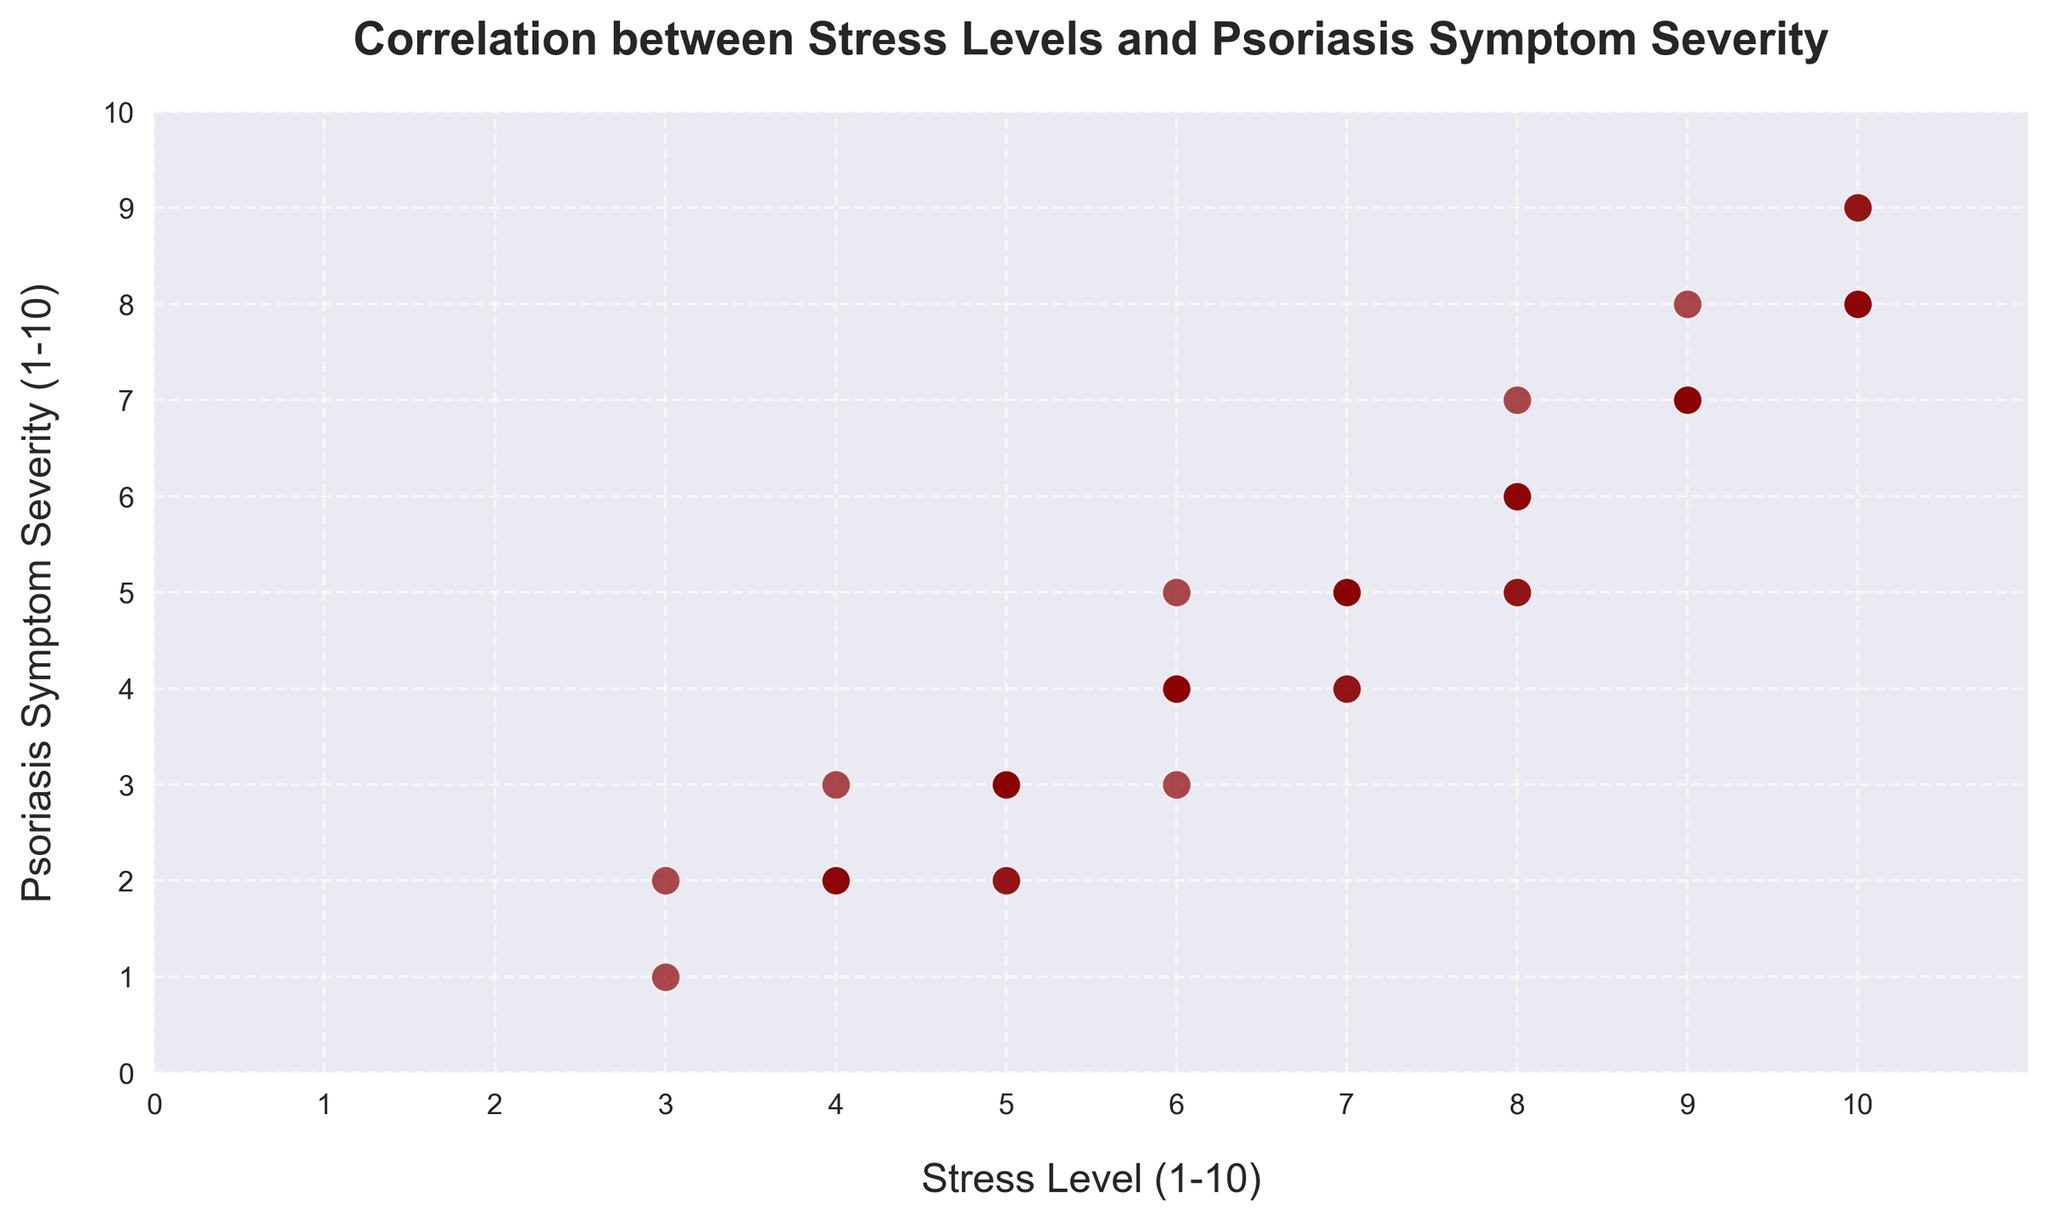What is the range of the stress levels shown in the plot? The stress levels range from the lowest point to the highest point plotted on the x-axis. From the plot, stress levels range from 3 to 10.
Answer: 3 to 10 Is there a pattern or trend observable between stress levels and psoriasis symptom severity? By examining the upward trend of the data points from left to right, there's a positive correlation where higher stress levels correspond to higher psoriasis symptom severity.
Answer: Positive correlation What is the psoriasis symptom severity when the stress level is 5? Looking at the plot, locate the data points where the stress level (x-axis) is 5. The corresponding psoriasis symptom severity values (y-axis) are 2 and 3.
Answer: 2 and 3 How many data points have a stress level of 10? Count the markers on the plot where the stress level (x-axis) is 10. There are four data points.
Answer: 4 Compare the psoriasis symptom severity at stress levels 7 and 8. Which has higher average severity? For stress level 7, the severity values are 4 and 5. For stress level 8, the severity values are 5, 6, 7, and 8. The average severity for stress level 7 is (4+5)/2 = 4.5, and for 8 is (5+6+7+8)/4 = 6.5.
Answer: 8 What is the average psoriasis symptom severity across all data points? Sum all psoriasis severity values and divide by the number of data points. (2+2+3+4+5+3+4+5+6+7+8+2+3+4+5+7+8+9+2+3+5+6+3+4+6+7+8+1+2+2+5+7+4+9+5+4+3+5+7+8) / 40 = 5
Answer: 5 At what stress level does psoriasis symptom severity reach 9? On the plot, find the data points where psoriasis severity (y-axis) is 9. The corresponding stress levels (x-axis) are 10 and 10.
Answer: 10 What's the highest psoriasis symptom severity recorded, and at what stress level does it occur? Check the highest point on the y-axis, which is 9, occurring at stress levels 9 and 10.
Answer: 9 at 9 and 10 